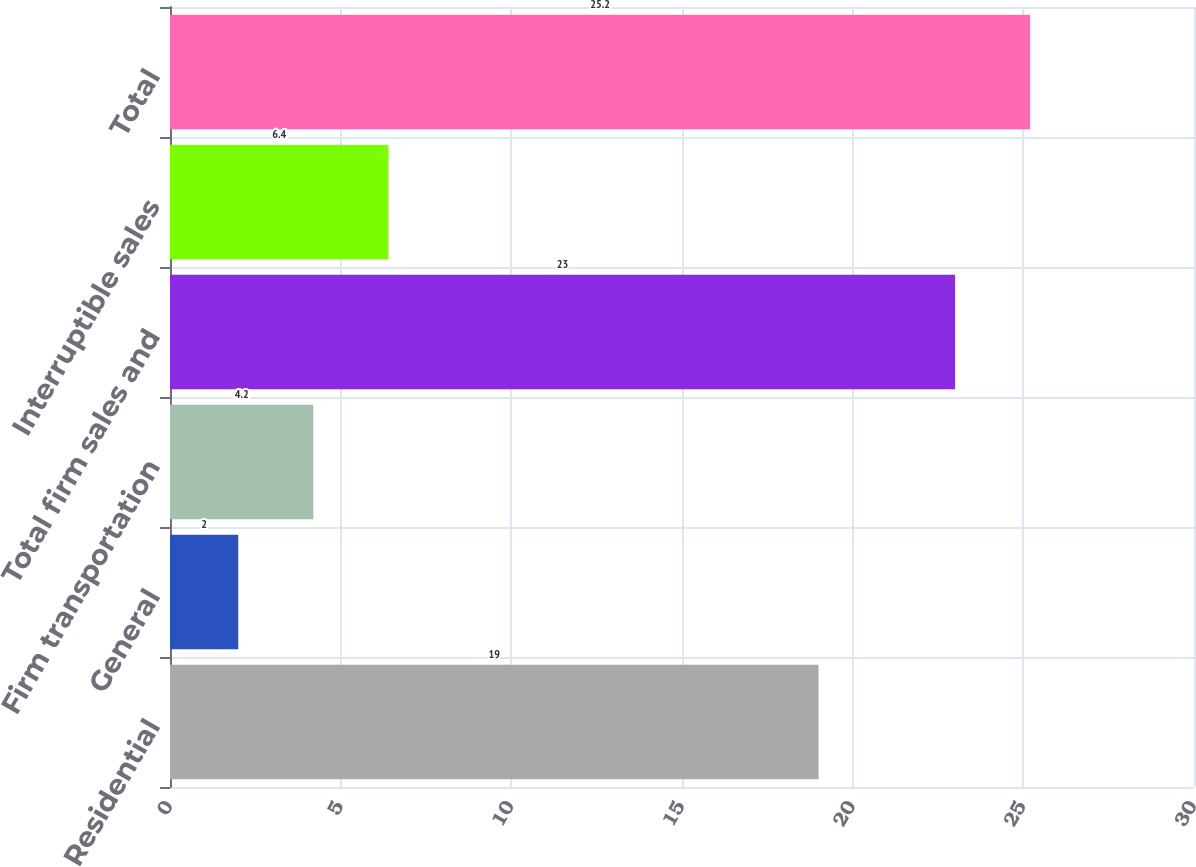Convert chart to OTSL. <chart><loc_0><loc_0><loc_500><loc_500><bar_chart><fcel>Residential<fcel>General<fcel>Firm transportation<fcel>Total firm sales and<fcel>Interruptible sales<fcel>Total<nl><fcel>19<fcel>2<fcel>4.2<fcel>23<fcel>6.4<fcel>25.2<nl></chart> 